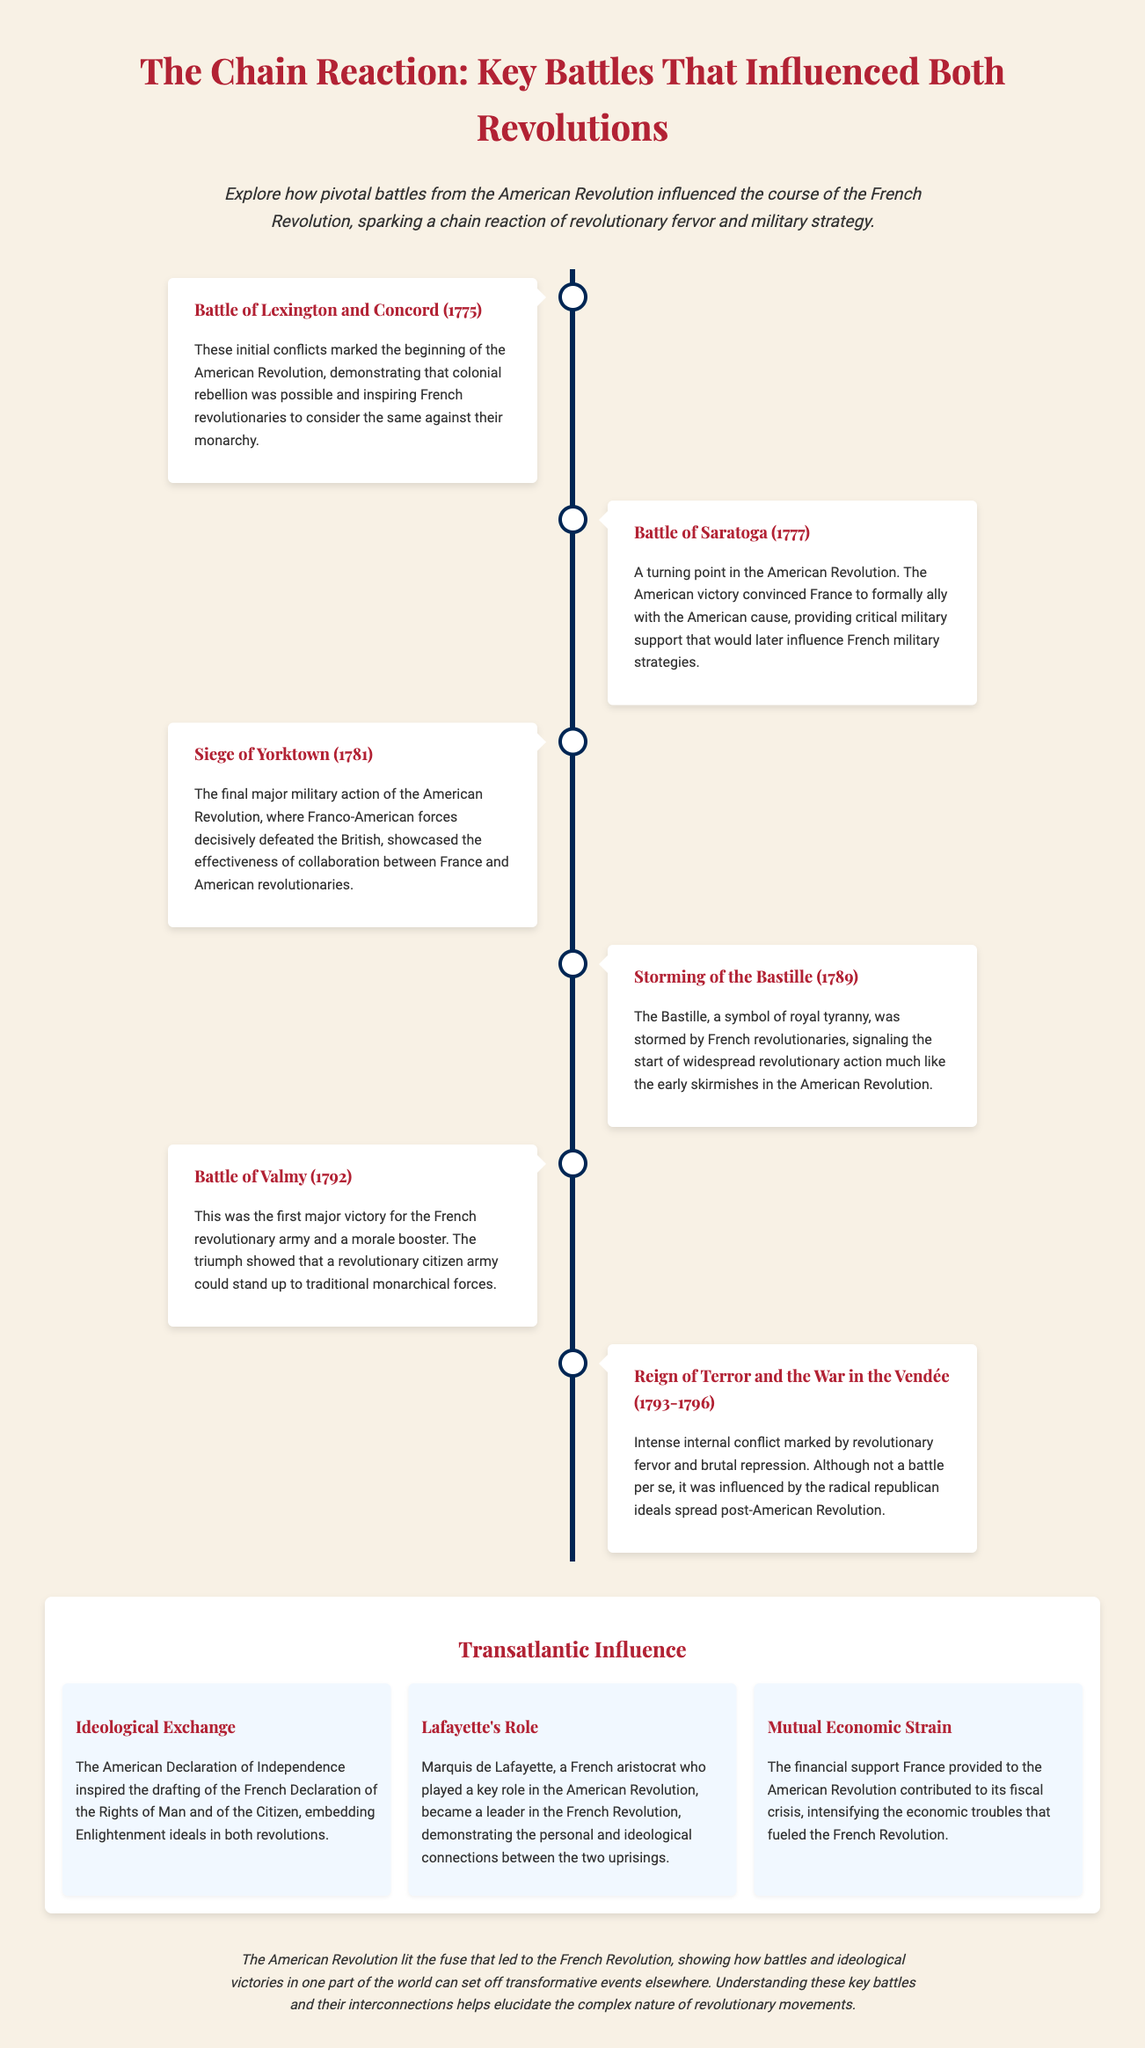What year did the Battle of Lexington and Concord occur? The document states that the Battle of Lexington and Concord took place in 1775.
Answer: 1775 What was a significant outcome of the Battle of Saratoga? The document mentions that the American victory at Saratoga convinced France to ally with the American cause.
Answer: Alliance with France What event marked the start of the French Revolution? According to the document, the storming of the Bastille signaled the beginning of widespread revolutionary action in France.
Answer: Storming of the Bastille Which battle showed that a revolutionary citizen army could stand up to monarchical forces? The document indicates that the Battle of Valmy was the first major victory for the French revolutionary army.
Answer: Battle of Valmy Who played a key role in both the American and French revolutions? The document highlights Marquis de Lafayette as a significant figure in both revolutionary movements.
Answer: Marquis de Lafayette What ideological document was inspired by the American Declaration of Independence? The French Declaration of the Rights of Man and of the Citizen was influenced by the American Declaration.
Answer: French Declaration of the Rights of Man and of the Citizen Which major event occurred from 1793 to 1796 in France? The document describes the Reign of Terror and the War in the Vendée as major internal conflicts during this time.
Answer: Reign of Terror What was a result of France's financial support to the American Revolution? The document states that the financial aid contributed to France's fiscal crisis, intensifying economic troubles.
Answer: Fiscal crisis How did battles in the American Revolution influence the French Revolution? The document suggests that the battles showed the possibility of rebellion and inspired the French revolutionaries.
Answer: Inspired rebellion 